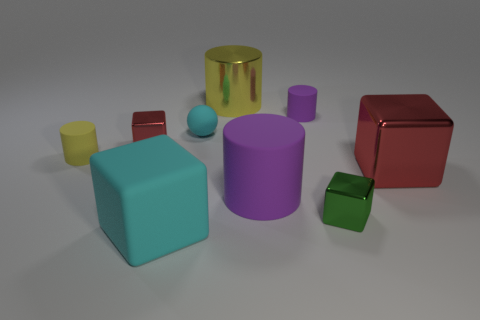Are there more red metallic blocks that are to the right of the green cube than small cyan matte things that are in front of the cyan rubber sphere?
Give a very brief answer. Yes. What number of other objects are there of the same shape as the small cyan object?
Provide a succinct answer. 0. Is there a big object that is behind the tiny rubber cylinder that is in front of the small red shiny object?
Your answer should be very brief. Yes. How many small shiny blocks are there?
Your response must be concise. 2. There is a tiny sphere; does it have the same color as the large block that is left of the tiny ball?
Provide a short and direct response. Yes. Is the number of tiny green cubes greater than the number of large things?
Offer a terse response. No. What number of other objects are the same size as the yellow matte cylinder?
Keep it short and to the point. 4. What is the yellow thing that is in front of the small cube that is on the left side of the big shiny object behind the small red metallic thing made of?
Give a very brief answer. Rubber. Are the tiny green object and the red object that is left of the cyan matte block made of the same material?
Provide a succinct answer. Yes. Is the number of small matte things that are in front of the small sphere less than the number of matte cylinders left of the tiny purple object?
Make the answer very short. Yes. 